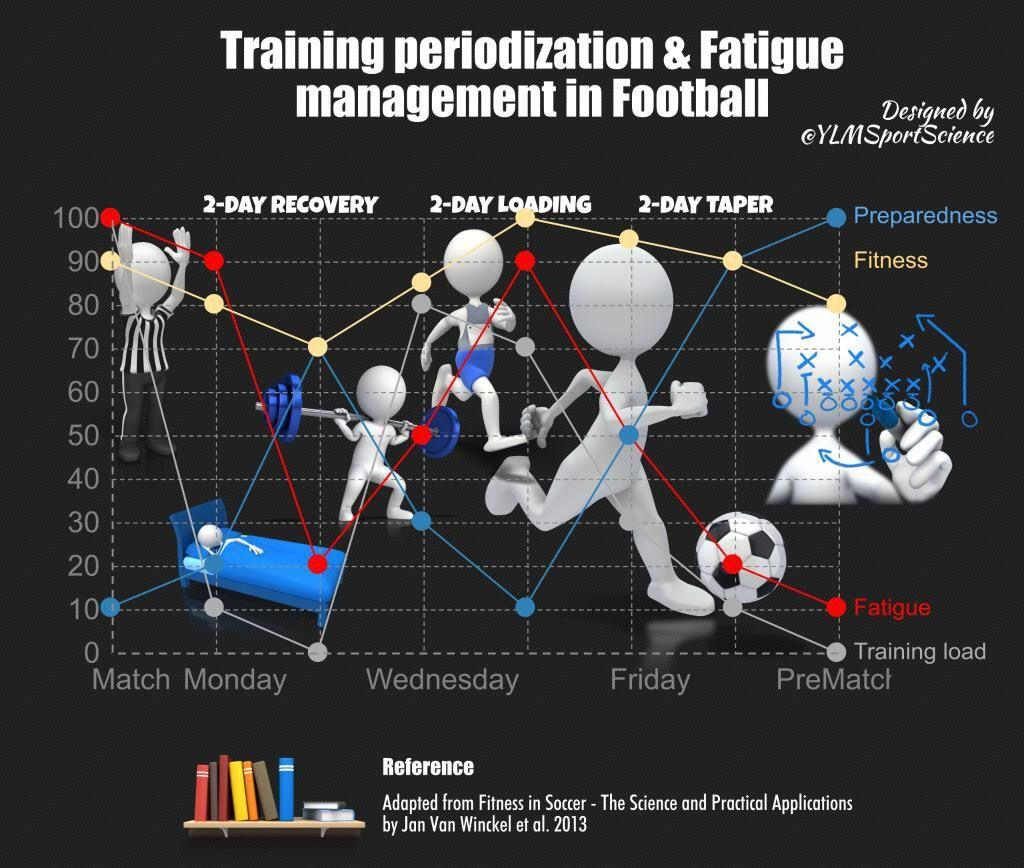Draw attention to some important aspects in this diagram. On which day of the week does training level have the lowest level, Monday, Tuesday, or Thursday? The answer is Tuesday. On Thursday, fatigue reaches its highest point. It is crucial to prioritize the aspects of training and fatigue management during pre-match to ensure optimal preparedness and physical fitness. During pre-match, preparedness, fatigue, or training load, the training load should be at its lowest possible level. On the day of the match, the three aspects of training and fatigue management that are most likely to be at their highest values are fitness, fatigue, and training load. 